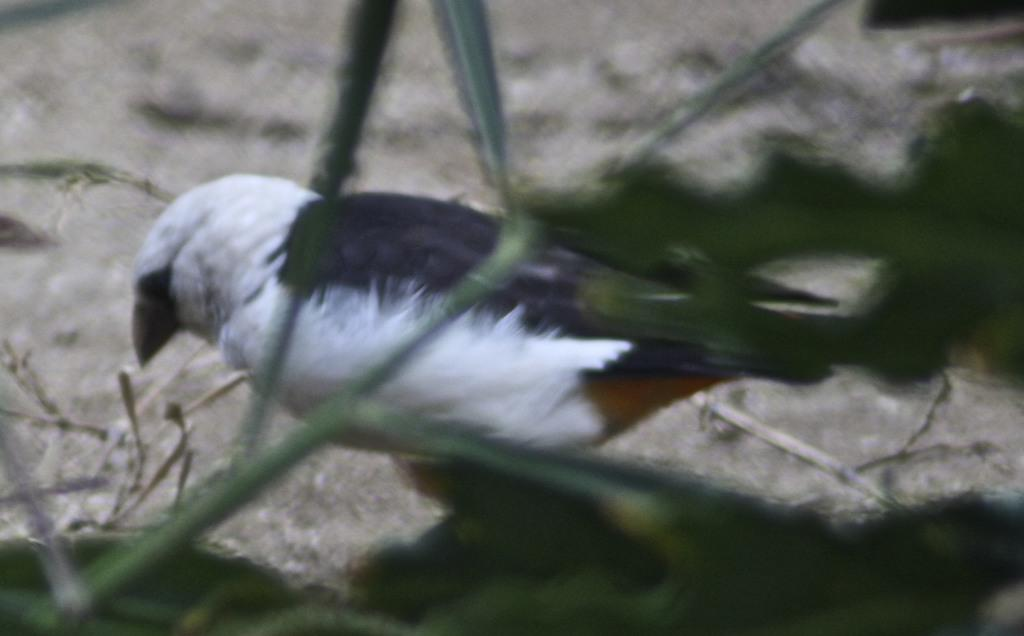What type of animal can be seen in the image? There is a bird in the image. What type of vegetation is visible in the background of the image? There is grass visible in the background of the image. How would you describe the appearance of the background in the image? The background appears blurry. What type of form does the bird's voice take in the image? The image does not depict the bird's voice, as it is a visual medium and cannot capture sound. 